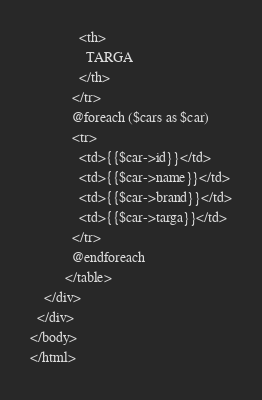<code> <loc_0><loc_0><loc_500><loc_500><_PHP_>              <th>
                TARGA
              </th>
            </tr>
            @foreach ($cars as $car)
            <tr>
              <td>{{$car->id}}</td>
              <td>{{$car->name}}</td>
              <td>{{$car->brand}}</td>
              <td>{{$car->targa}}</td>
            </tr>
            @endforeach
          </table>
    </div>
  </div>
</body>
</html></code> 